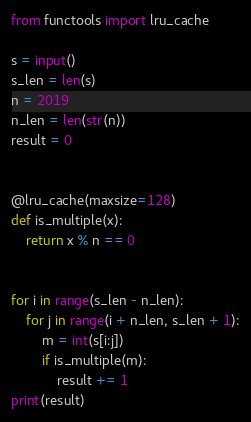<code> <loc_0><loc_0><loc_500><loc_500><_Python_>from functools import lru_cache

s = input()
s_len = len(s)
n = 2019
n_len = len(str(n))
result = 0


@lru_cache(maxsize=128)
def is_multiple(x):
    return x % n == 0


for i in range(s_len - n_len):
    for j in range(i + n_len, s_len + 1):
        m = int(s[i:j])
        if is_multiple(m):
            result += 1
print(result)</code> 